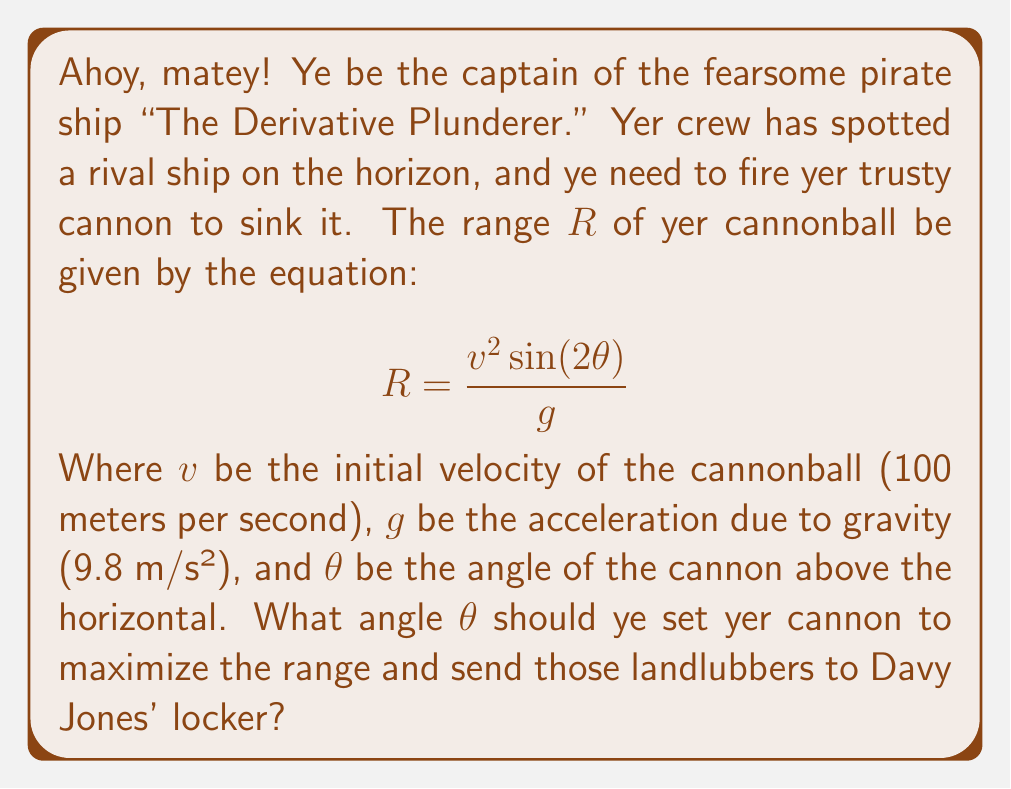Show me your answer to this math problem. To find the optimal angle for maximum range, we need to find the maximum value of the range function $R(\theta)$. Here's how we can do it:

1) First, we need to find the derivative of $R$ with respect to $\theta$:

   $$\frac{dR}{d\theta} = \frac{v^2}{g} \cdot 2\cos(2\theta)$$

2) To find the maximum, we set this derivative equal to zero:

   $$\frac{v^2}{g} \cdot 2\cos(2\theta) = 0$$

3) Solving this equation:

   $$\cos(2\theta) = 0$$

4) We know that cosine is zero when its argument is $\frac{\pi}{2}$ or $\frac{3\pi}{2}$. So:

   $$2\theta = \frac{\pi}{2}$$ or $$2\theta = \frac{3\pi}{2}$$

5) Solving for $\theta$:

   $$\theta = \frac{\pi}{4}$$ or $$\theta = \frac{3\pi}{4}$$

6) The angle $\frac{3\pi}{4}$ would result in the cannonball being fired backwards, so we can discard this solution.

7) Therefore, the optimal angle is $\frac{\pi}{4}$ radians, which is equivalent to 45 degrees.

8) We can confirm this is a maximum (not a minimum) by checking the second derivative is negative at this point.
Answer: 45° 